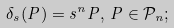Convert formula to latex. <formula><loc_0><loc_0><loc_500><loc_500>\delta _ { s } ( P ) = s ^ { n } P , \, P \in \mathcal { P } _ { n } ;</formula> 